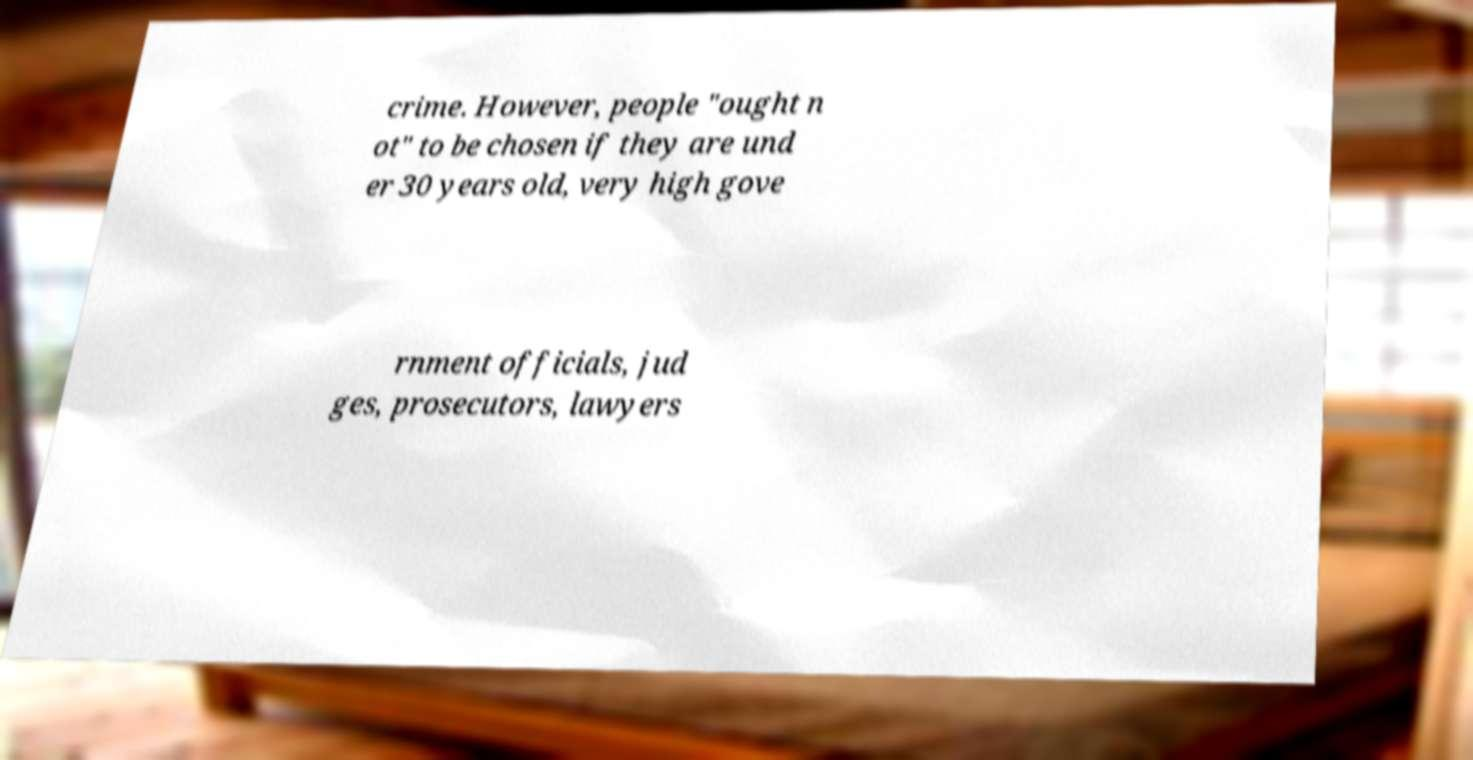Could you extract and type out the text from this image? crime. However, people "ought n ot" to be chosen if they are und er 30 years old, very high gove rnment officials, jud ges, prosecutors, lawyers 